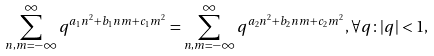Convert formula to latex. <formula><loc_0><loc_0><loc_500><loc_500>\sum ^ { \infty } _ { n , m = - \infty } q ^ { a _ { 1 } n ^ { 2 } + b _ { 1 } n m + c _ { 1 } m ^ { 2 } } = \sum ^ { \infty } _ { n , m = - \infty } q ^ { a _ { 2 } n ^ { 2 } + b _ { 2 } n m + c _ { 2 } m ^ { 2 } } , \forall q \colon | q | < 1 ,</formula> 